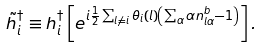Convert formula to latex. <formula><loc_0><loc_0><loc_500><loc_500>\tilde { h } _ { i } ^ { \dagger } \equiv h _ { i } ^ { \dagger } \left [ e ^ { i \frac { 1 } { 2 } \sum _ { l \neq i } \theta _ { i } ( l ) \left ( \sum _ { \alpha } \alpha n _ { l \alpha } ^ { b } - 1 \right ) } \right ] .</formula> 